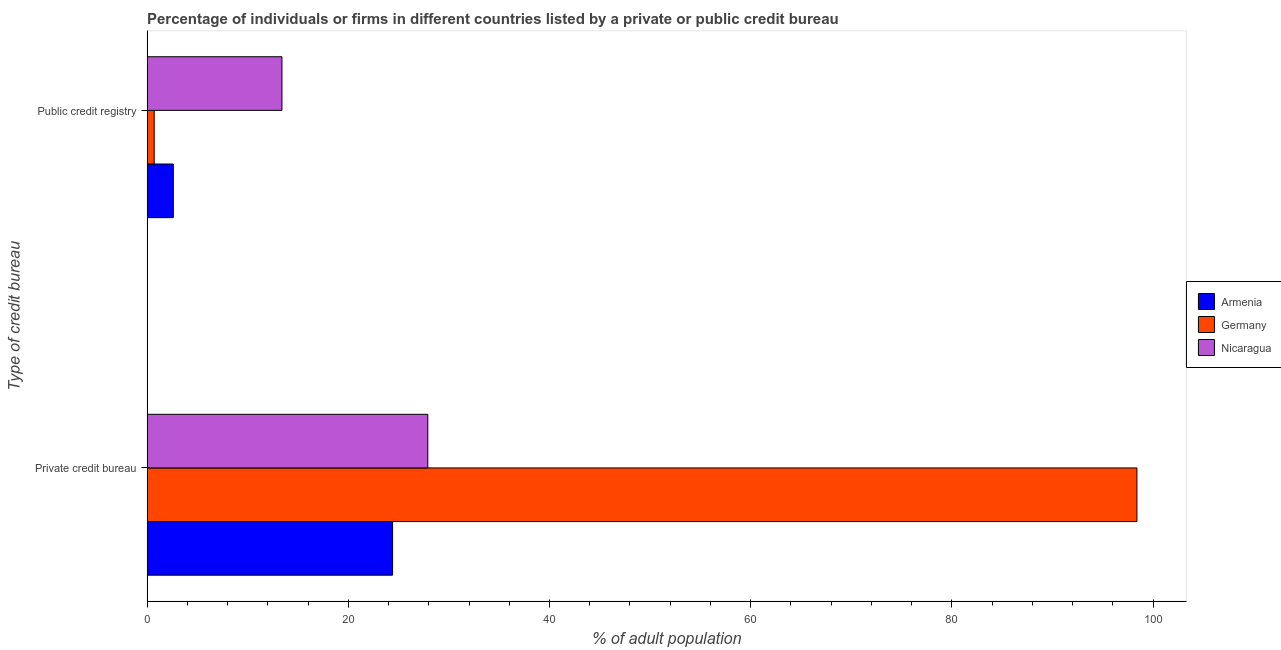Are the number of bars per tick equal to the number of legend labels?
Your answer should be compact. Yes. Are the number of bars on each tick of the Y-axis equal?
Provide a succinct answer. Yes. What is the label of the 1st group of bars from the top?
Provide a succinct answer. Public credit registry. What is the percentage of firms listed by private credit bureau in Germany?
Offer a very short reply. 98.4. Across all countries, what is the maximum percentage of firms listed by private credit bureau?
Keep it short and to the point. 98.4. In which country was the percentage of firms listed by private credit bureau maximum?
Your answer should be very brief. Germany. What is the difference between the percentage of firms listed by public credit bureau in Armenia and that in Nicaragua?
Provide a short and direct response. -10.8. What is the difference between the percentage of firms listed by private credit bureau in Germany and the percentage of firms listed by public credit bureau in Armenia?
Your answer should be very brief. 95.8. What is the average percentage of firms listed by private credit bureau per country?
Keep it short and to the point. 50.23. What is the difference between the percentage of firms listed by private credit bureau and percentage of firms listed by public credit bureau in Germany?
Your answer should be compact. 97.7. In how many countries, is the percentage of firms listed by public credit bureau greater than 76 %?
Provide a short and direct response. 0. What is the ratio of the percentage of firms listed by private credit bureau in Armenia to that in Nicaragua?
Ensure brevity in your answer.  0.87. What does the 3rd bar from the top in Private credit bureau represents?
Offer a very short reply. Armenia. What does the 3rd bar from the bottom in Public credit registry represents?
Your answer should be very brief. Nicaragua. How many bars are there?
Your response must be concise. 6. Are all the bars in the graph horizontal?
Keep it short and to the point. Yes. Are the values on the major ticks of X-axis written in scientific E-notation?
Make the answer very short. No. Does the graph contain grids?
Give a very brief answer. No. How many legend labels are there?
Your answer should be compact. 3. How are the legend labels stacked?
Your response must be concise. Vertical. What is the title of the graph?
Provide a short and direct response. Percentage of individuals or firms in different countries listed by a private or public credit bureau. What is the label or title of the X-axis?
Your answer should be very brief. % of adult population. What is the label or title of the Y-axis?
Offer a very short reply. Type of credit bureau. What is the % of adult population of Armenia in Private credit bureau?
Provide a succinct answer. 24.4. What is the % of adult population in Germany in Private credit bureau?
Give a very brief answer. 98.4. What is the % of adult population of Nicaragua in Private credit bureau?
Your answer should be very brief. 27.9. What is the % of adult population in Germany in Public credit registry?
Make the answer very short. 0.7. What is the % of adult population in Nicaragua in Public credit registry?
Your answer should be very brief. 13.4. Across all Type of credit bureau, what is the maximum % of adult population of Armenia?
Offer a very short reply. 24.4. Across all Type of credit bureau, what is the maximum % of adult population in Germany?
Provide a short and direct response. 98.4. Across all Type of credit bureau, what is the maximum % of adult population of Nicaragua?
Give a very brief answer. 27.9. Across all Type of credit bureau, what is the minimum % of adult population in Germany?
Offer a very short reply. 0.7. What is the total % of adult population of Germany in the graph?
Offer a terse response. 99.1. What is the total % of adult population of Nicaragua in the graph?
Offer a very short reply. 41.3. What is the difference between the % of adult population in Armenia in Private credit bureau and that in Public credit registry?
Ensure brevity in your answer.  21.8. What is the difference between the % of adult population in Germany in Private credit bureau and that in Public credit registry?
Keep it short and to the point. 97.7. What is the difference between the % of adult population of Armenia in Private credit bureau and the % of adult population of Germany in Public credit registry?
Ensure brevity in your answer.  23.7. What is the difference between the % of adult population of Germany in Private credit bureau and the % of adult population of Nicaragua in Public credit registry?
Give a very brief answer. 85. What is the average % of adult population in Armenia per Type of credit bureau?
Your response must be concise. 13.5. What is the average % of adult population in Germany per Type of credit bureau?
Give a very brief answer. 49.55. What is the average % of adult population in Nicaragua per Type of credit bureau?
Provide a short and direct response. 20.65. What is the difference between the % of adult population of Armenia and % of adult population of Germany in Private credit bureau?
Ensure brevity in your answer.  -74. What is the difference between the % of adult population of Armenia and % of adult population of Nicaragua in Private credit bureau?
Provide a succinct answer. -3.5. What is the difference between the % of adult population in Germany and % of adult population in Nicaragua in Private credit bureau?
Offer a terse response. 70.5. What is the difference between the % of adult population of Armenia and % of adult population of Nicaragua in Public credit registry?
Ensure brevity in your answer.  -10.8. What is the difference between the % of adult population in Germany and % of adult population in Nicaragua in Public credit registry?
Your answer should be compact. -12.7. What is the ratio of the % of adult population of Armenia in Private credit bureau to that in Public credit registry?
Offer a terse response. 9.38. What is the ratio of the % of adult population in Germany in Private credit bureau to that in Public credit registry?
Provide a short and direct response. 140.57. What is the ratio of the % of adult population of Nicaragua in Private credit bureau to that in Public credit registry?
Offer a terse response. 2.08. What is the difference between the highest and the second highest % of adult population in Armenia?
Keep it short and to the point. 21.8. What is the difference between the highest and the second highest % of adult population in Germany?
Offer a very short reply. 97.7. What is the difference between the highest and the second highest % of adult population in Nicaragua?
Keep it short and to the point. 14.5. What is the difference between the highest and the lowest % of adult population in Armenia?
Give a very brief answer. 21.8. What is the difference between the highest and the lowest % of adult population in Germany?
Give a very brief answer. 97.7. 